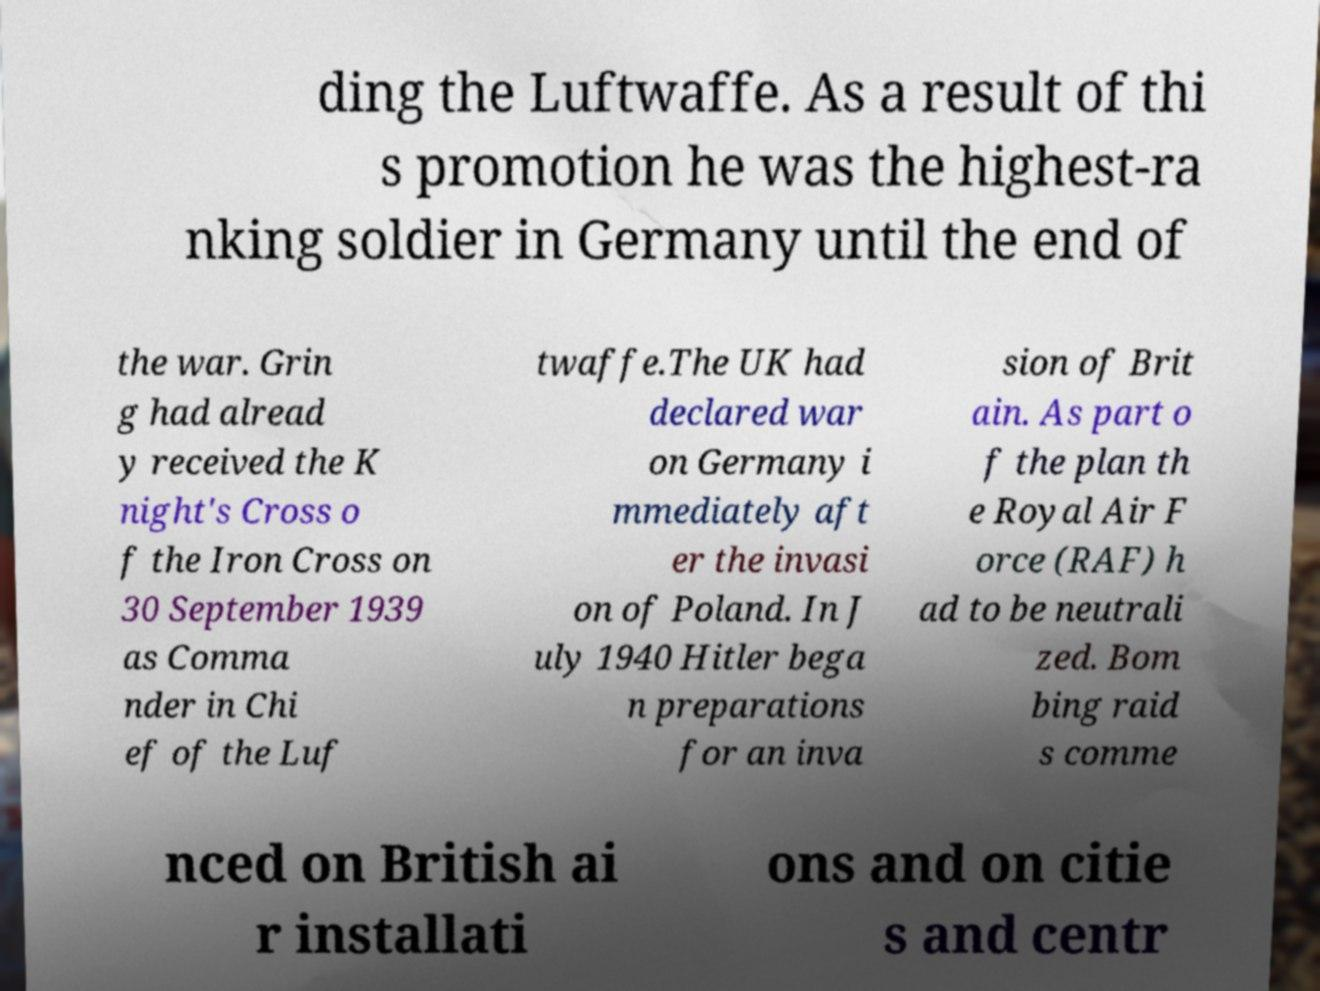For documentation purposes, I need the text within this image transcribed. Could you provide that? ding the Luftwaffe. As a result of thi s promotion he was the highest-ra nking soldier in Germany until the end of the war. Grin g had alread y received the K night's Cross o f the Iron Cross on 30 September 1939 as Comma nder in Chi ef of the Luf twaffe.The UK had declared war on Germany i mmediately aft er the invasi on of Poland. In J uly 1940 Hitler bega n preparations for an inva sion of Brit ain. As part o f the plan th e Royal Air F orce (RAF) h ad to be neutrali zed. Bom bing raid s comme nced on British ai r installati ons and on citie s and centr 